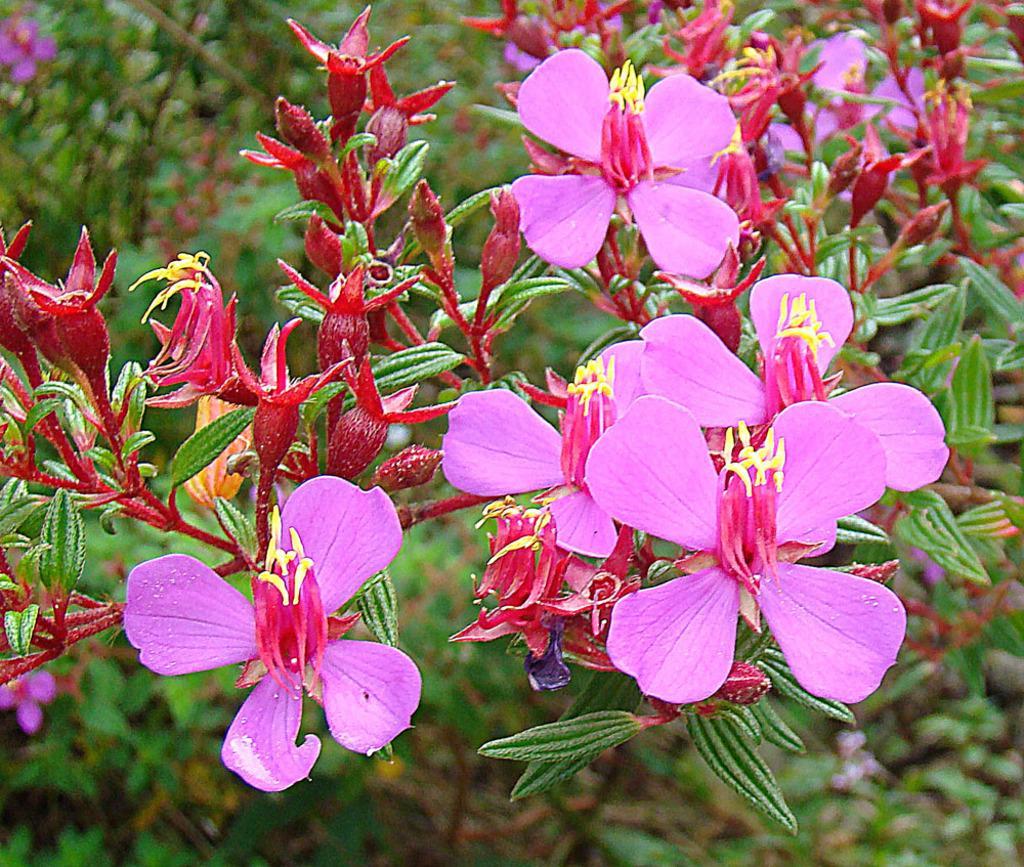Can you describe this image briefly? In this picture we can see a few pink flowers, red buds and some green leaves. Background is blurry. 